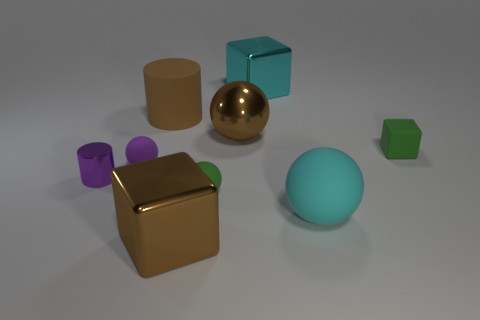What is the material of the tiny purple cylinder?
Keep it short and to the point. Metal. There is a big brown metal sphere; are there any large brown metal objects in front of it?
Offer a very short reply. Yes. The brown cylinder that is made of the same material as the small green cube is what size?
Offer a very short reply. Large. How many small cylinders are the same color as the small rubber cube?
Keep it short and to the point. 0. Are there fewer brown rubber cylinders that are on the left side of the small cylinder than cylinders in front of the metal ball?
Offer a very short reply. Yes. What is the size of the sphere that is on the right side of the big cyan metallic cube?
Your response must be concise. Large. There is a block that is the same color as the large metal ball; what size is it?
Ensure brevity in your answer.  Large. Are there any tiny gray cylinders that have the same material as the big cylinder?
Offer a very short reply. No. Does the large cyan cube have the same material as the big brown cylinder?
Keep it short and to the point. No. What is the color of the matte cube that is the same size as the purple shiny thing?
Keep it short and to the point. Green. 